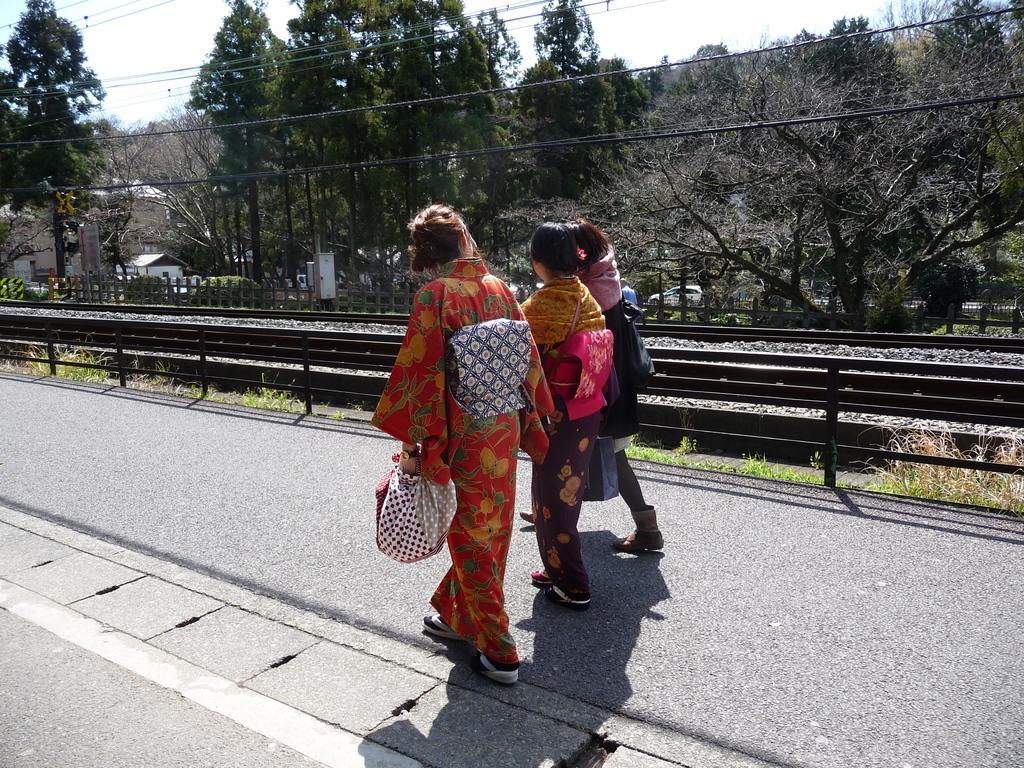Describe this image in one or two sentences. In this image we can see people walking. At the bottom of the image there is road. In the background of the image there are trees. There are railway tracks. 